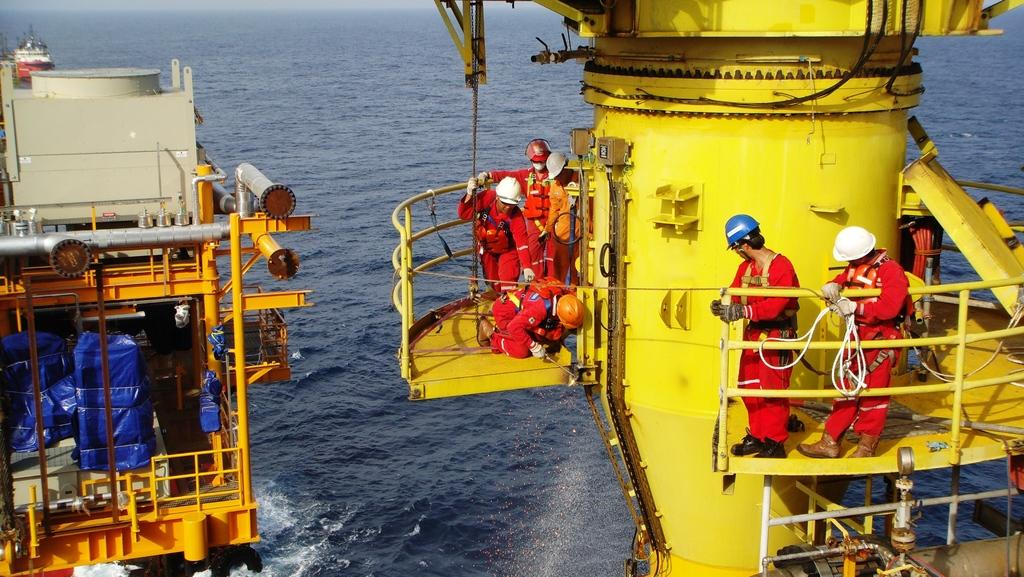What are the men in the foreground of the picture doing? The men in the foreground of the picture are standing and working. Where are the men located? The men are on a ship. Can you describe the background of the image? There is another ship in the background of the image. What is visible in the image besides the men and ships? Water is visible in the image. What type of button can be seen on the example in the image? There is no button or example present in the image; it features men working on a ship with water visible in the background. 